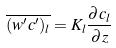<formula> <loc_0><loc_0><loc_500><loc_500>\overline { ( w ^ { \prime } c ^ { \prime } ) _ { l } } = K _ { l } \frac { \partial c _ { l } } { \partial z }</formula> 